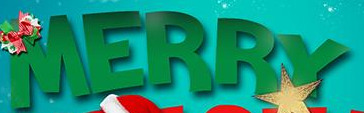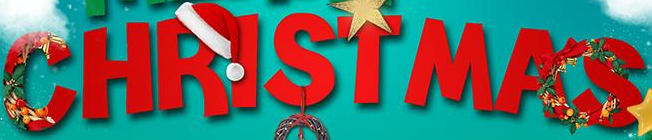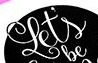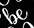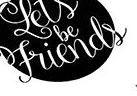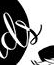Identify the words shown in these images in order, separated by a semicolon. MERRY; CHRISTMAS; Let's; be; Friends; ds 